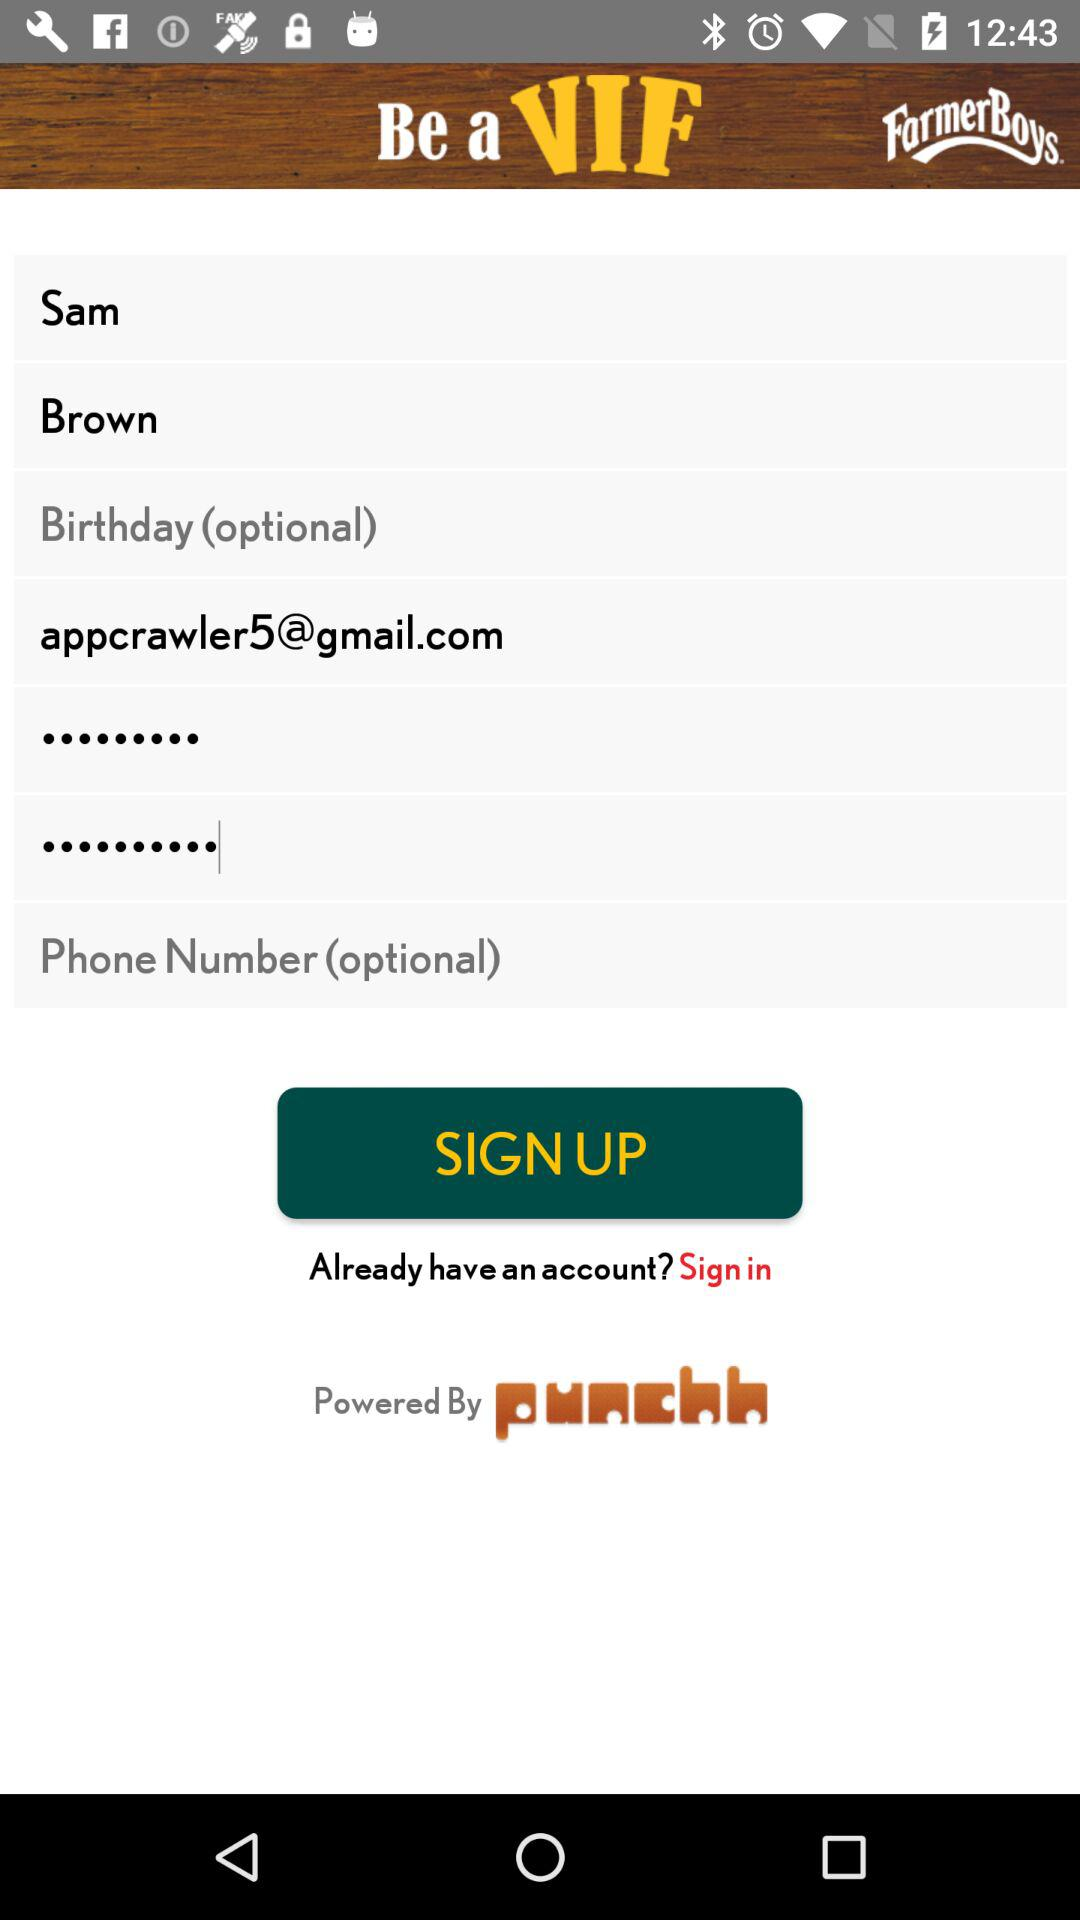Is birthday given?
When the provided information is insufficient, respond with <no answer>. <no answer> 